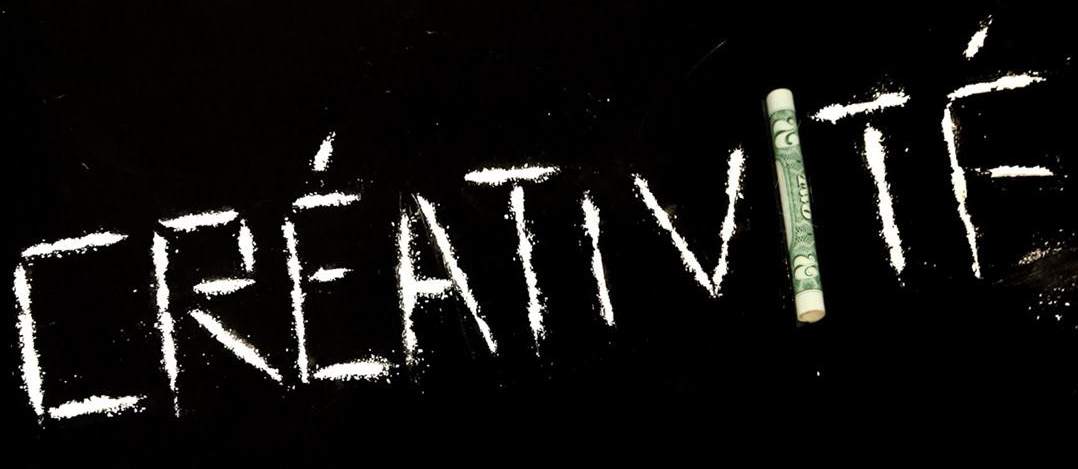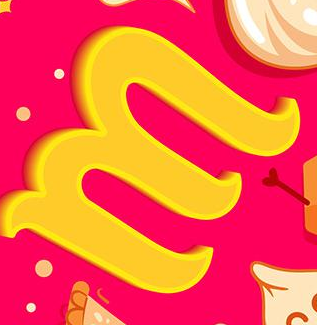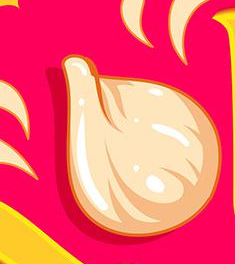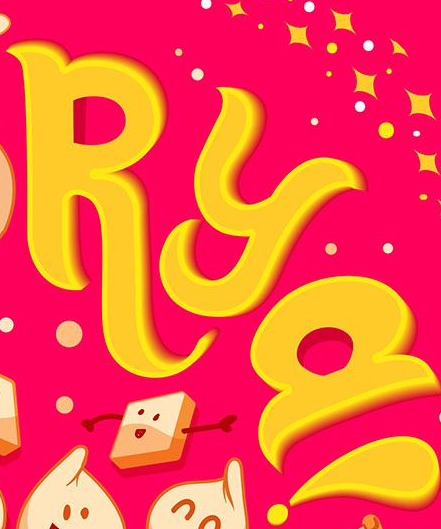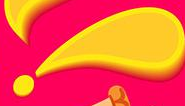What text appears in these images from left to right, separated by a semicolon? CRÉATIVITḞ; M; #; RYa; ! 